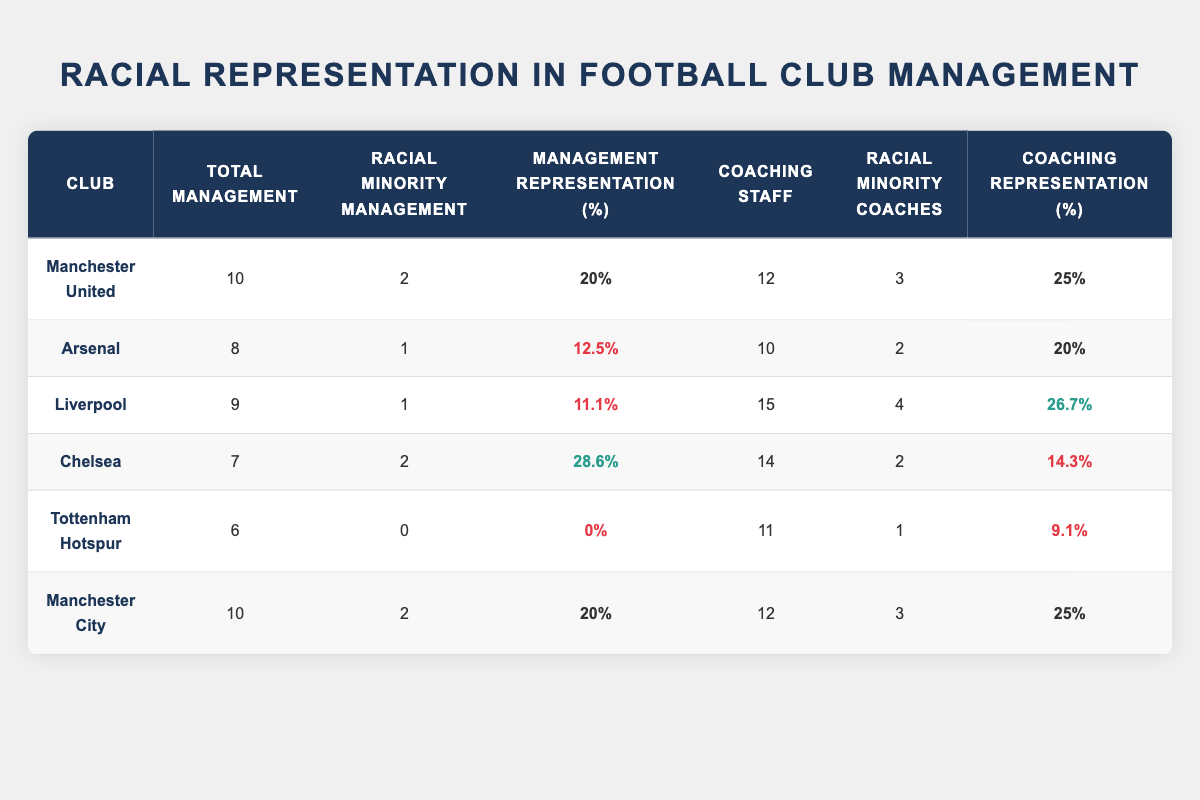What is the total number of management staff at Arsenal? From the table, we can directly see that the total management staff at Arsenal is listed under the "Total Management" column. The value provided is 8.
Answer: 8 What percentage of management at Chelsea are from racial minorities? Looking at the "Percentage Representation" column for Chelsea, the value is given as 28.6%, which indicates that 28.6% of Chelsea's management staff are from racial minorities.
Answer: 28.6% Which club has the highest percentage representation of racial minorities in coaching staff? By examining the "Percentage Coaching Representation" column, we notice that Liverpool has the highest value at 26.7%, which is greater than the percentages for the other clubs listed.
Answer: Liverpool Is Tottenham Hotspur's management representation of racial minorities above 10%? In the table, the "Percentage Representation" for Tottenham Hotspur is listed as 0%, which is clearly below 10%. Therefore, the statement is false.
Answer: No What is the total number of racial minority coaches across all clubs? To find the total number of racial minority coaches, we must sum up the values in the "Racial Minority Coaches" column: 3 (Manchester United) + 2 (Arsenal) + 4 (Liverpool) + 2 (Chelsea) + 1 (Tottenham Hotspur) + 3 (Manchester City) = 15.
Answer: 15 How does the percentage representation of racial minorities in management at Manchester City compare to that at Liverpool? Manchester City has a percentage representation of 20%, while Liverpool is at 11.1%. Comparing these, we find Manchester City's representation is higher than Liverpool's by 8.9%.
Answer: Manchester City is higher What is the average percentage representation of racial minorities in management across all clubs? First, we need to sum the percentage representation for each club: 20 + 12.5 + 11.1 + 28.6 + 0 + 20 = 92.2. There are 6 clubs, so to find the average, we divide the sum by 6: 92.2 / 6 = 15.37.
Answer: 15.37 Which club has a higher percentage of racial minority coaches: Manchester United or Chelsea? In the "Percentage Coaching Representation" column, Manchester United is at 25%, while Chelsea is at 14.3%. Comparing these two, Manchester United's percentage is higher than Chelsea's.
Answer: Manchester United has a higher percentage Are there any clubs in the table with 0% representation of racial minorities in their management? Upon checking the "Percentage Representation" column, it shows that Tottenham Hotspur is the only club listed with 0% representation in their management. This confirms that the statement is true.
Answer: Yes 